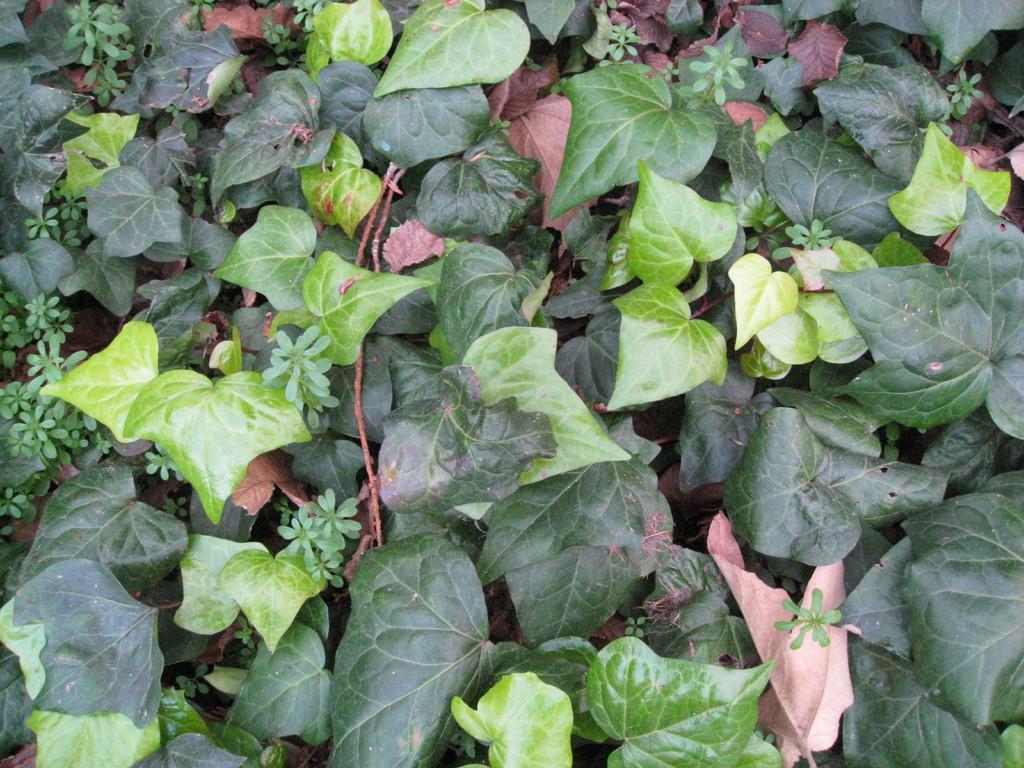In one or two sentences, can you explain what this image depicts? In this picture we can see leaves and plants. 